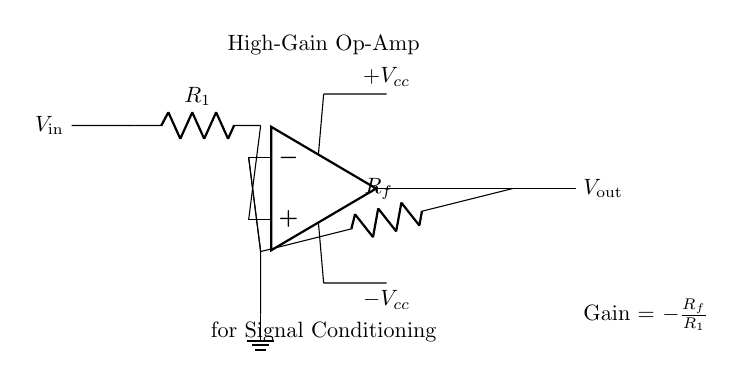What is the type of amplifier depicted? The circuit diagram shows a high-gain operational amplifier, identifiable by the symbol used and its configuration.
Answer: high-gain operational amplifier What is the input voltage labeled as? The input voltage in the circuit is labeled as V in, which corresponds to the terminal connected to the resistor R1.
Answer: V in What component is connected as feedback in the circuit? The feedback component in the amplifier circuit is the resistor labeled R f, which connects the output to the inverting input of the op-amp.
Answer: R f What is the relationship between output and input voltages? The gain equation is presented in the circuit, showing that V out is a function of V in modified by the resistors R1 and Rf: Gain equals negative R f over R1.
Answer: Gain = negative R f over R1 What are the power supply voltages labeled in the circuit? The circuit diagram specifies two supply voltages for the op-amp: one labeled as plus V cc for the positive rail and the other as minus V cc for the negative rail.
Answer: plus V cc and minus V cc What is the purpose of the high-gain op-amp in this circuit? The circuit is intended for signal conditioning in data acquisition systems, which involves amplifying weak signals to detectable levels.
Answer: signal conditioning What is the configuration of the resistors in this circuit? The configuration of the resistors is a feedback loop where R1 is in series with the input voltage and Rf is feedback to the inverting input of the op-amp.
Answer: feedback loop 